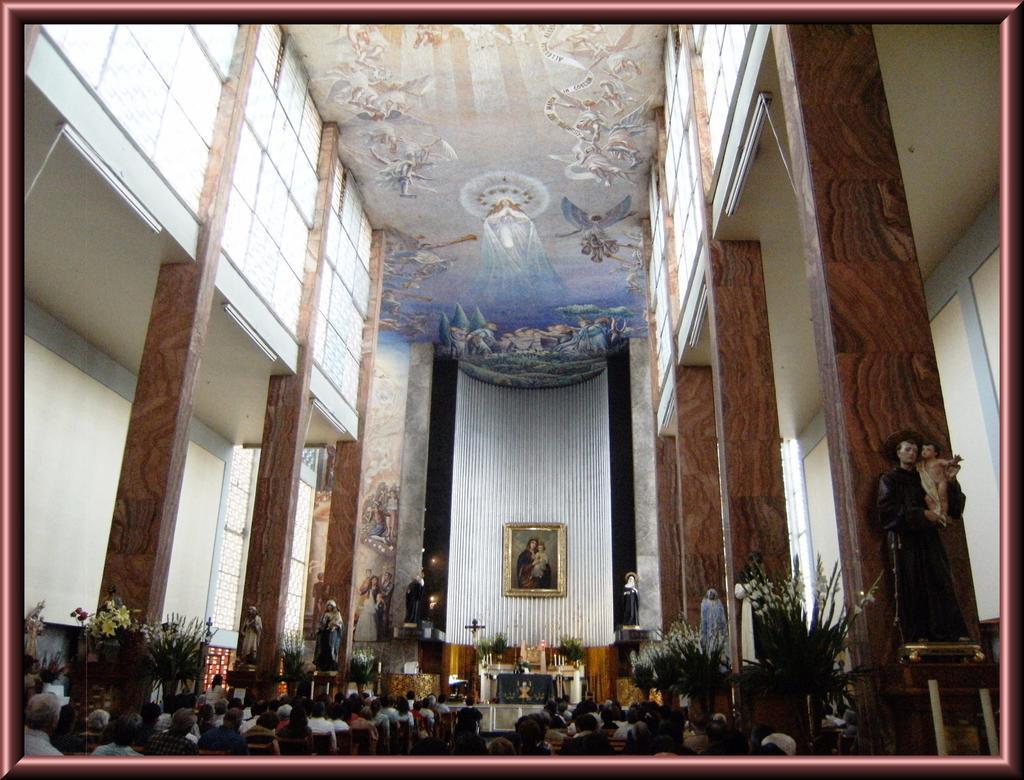How would you summarize this image in a sentence or two? In this image, we can see the inside view of a church. At the bottom of the image, we can see people, sculptures, decorative flowers and few objects. In the middle of the image, we can see the wall, pillars and photo frame. Top of the image, we can see ceiling with painting. 